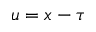<formula> <loc_0><loc_0><loc_500><loc_500>u = x - \tau</formula> 